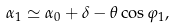Convert formula to latex. <formula><loc_0><loc_0><loc_500><loc_500>\alpha _ { 1 } \simeq \alpha _ { 0 } + \delta - \theta \cos \varphi _ { 1 } ,</formula> 